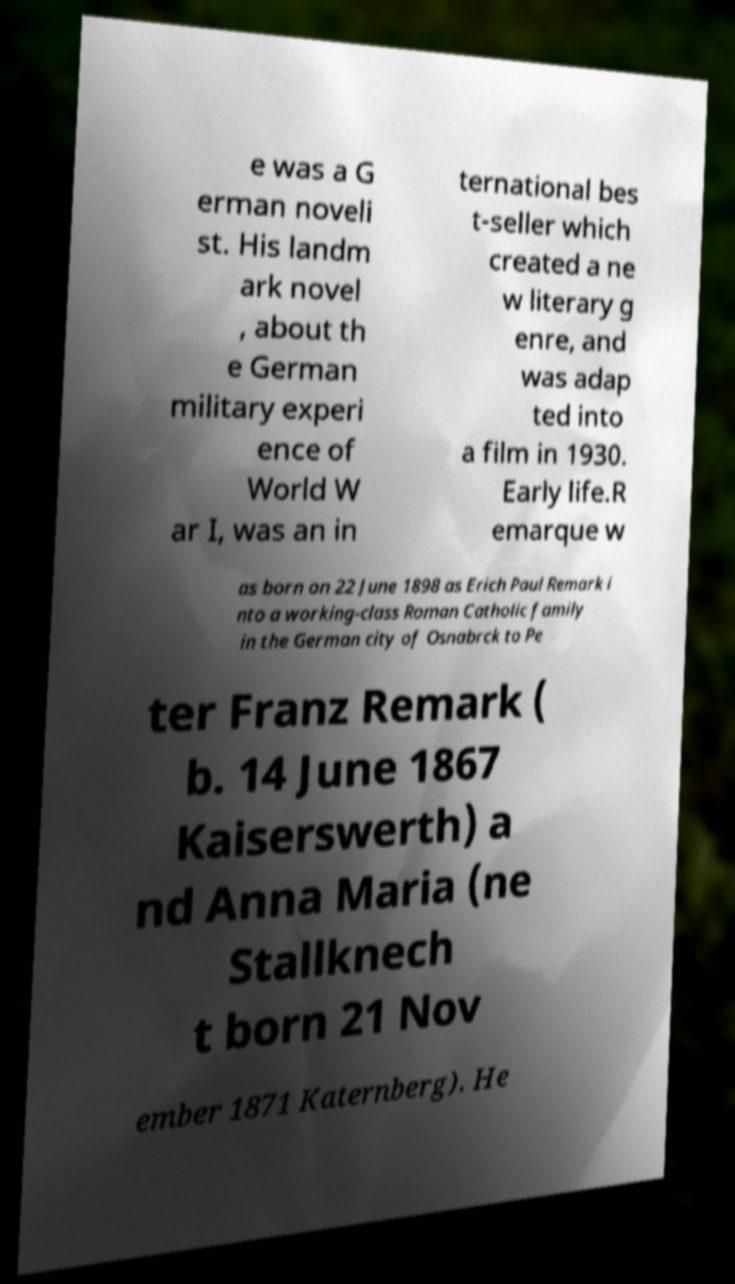I need the written content from this picture converted into text. Can you do that? e was a G erman noveli st. His landm ark novel , about th e German military experi ence of World W ar I, was an in ternational bes t-seller which created a ne w literary g enre, and was adap ted into a film in 1930. Early life.R emarque w as born on 22 June 1898 as Erich Paul Remark i nto a working-class Roman Catholic family in the German city of Osnabrck to Pe ter Franz Remark ( b. 14 June 1867 Kaiserswerth) a nd Anna Maria (ne Stallknech t born 21 Nov ember 1871 Katernberg). He 